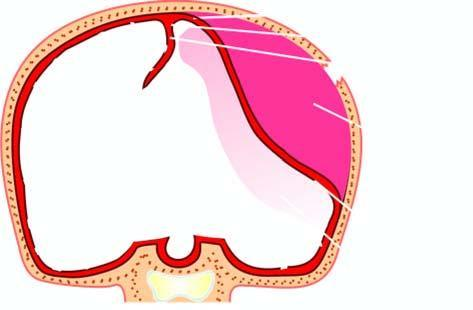does oxygen result from rupture of artery following skull fracture resulting in accumulation of arterial blood between the skull and the dura?
Answer the question using a single word or phrase. No 